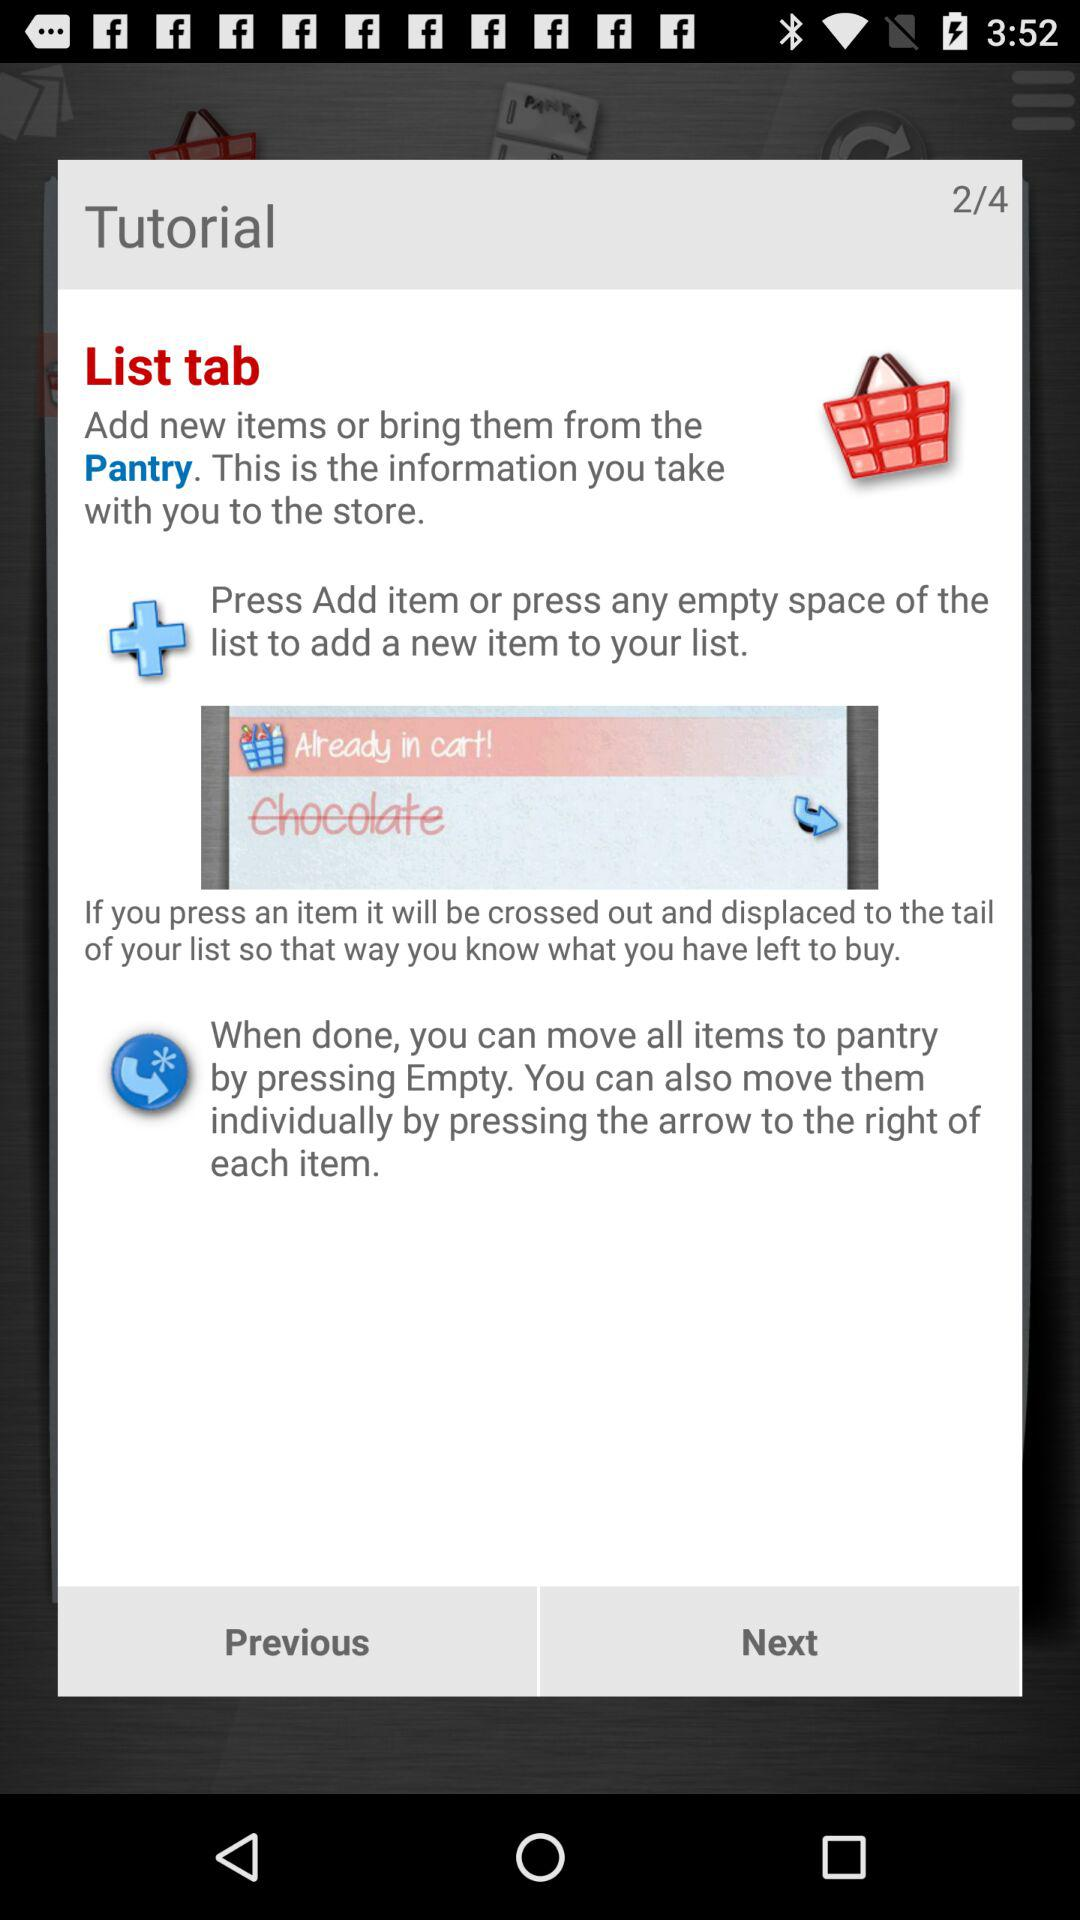Which page am I on? You are on the second page. 